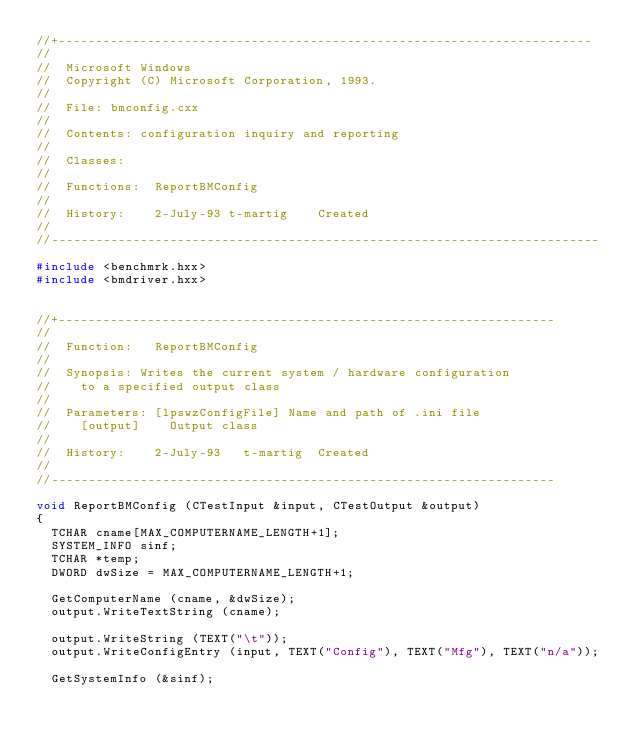Convert code to text. <code><loc_0><loc_0><loc_500><loc_500><_C++_>//+------------------------------------------------------------------------
//
//  Microsoft Windows
//  Copyright (C) Microsoft Corporation, 1993.
//
//  File:	bmconfig.cxx
//
//  Contents:	configuration inquiry and reporting
//
//  Classes:	
//
//  Functions:	ReportBMConfig
//
//  History:    2-July-93 t-martig    Created
//
//--------------------------------------------------------------------------

#include <benchmrk.hxx>
#include <bmdriver.hxx>


//+-------------------------------------------------------------------
//
//  Function: 	ReportBMConfig
//
//  Synopsis:	Writes the current system / hardware configuration
//		to a specified output class
//
//  Parameters: [lpswzConfigFile]	Name and path of .ini file 
//		[output]		Output class
//
//  History:   	2-July-93   t-martig	Created
//
//--------------------------------------------------------------------

void ReportBMConfig (CTestInput &input, CTestOutput &output)
{
	TCHAR cname[MAX_COMPUTERNAME_LENGTH+1];
	SYSTEM_INFO sinf;
	TCHAR *temp;
	DWORD dwSize = MAX_COMPUTERNAME_LENGTH+1;

	GetComputerName (cname, &dwSize);
	output.WriteTextString (cname);

	output.WriteString (TEXT("\t"));
	output.WriteConfigEntry (input, TEXT("Config"), TEXT("Mfg"), TEXT("n/a"));

	GetSystemInfo (&sinf);</code> 